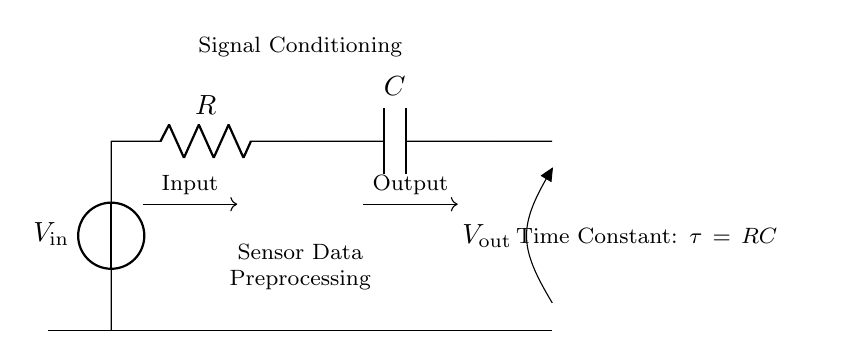What components are present in the circuit? The circuit contains a voltage source, resistor, and capacitor.
Answer: voltage source, resistor, capacitor What is the function of the resistor? The resistor limits the current flow and helps in shaping the voltage over time in the RC circuit.
Answer: limit current What does the capacitor do in the circuit? The capacitor stores and releases electrical energy, affecting the voltage output over time.
Answer: store energy What is the time constant (tau) of the circuit? The time constant is defined as the product of resistance and capacitance, given by tau equals R times C.
Answer: tau equals RC What is the relationship between input and output voltage? The output voltage is a smoothed version of the input voltage, transformed by the RC time constant that filters rapid changes.
Answer: smoothed version How does the time constant affect the output signal? A larger time constant results in slower charging and discharging of the capacitor, leading to a more pronounced smoothing effect on the output signal.
Answer: slower smoothing effect 